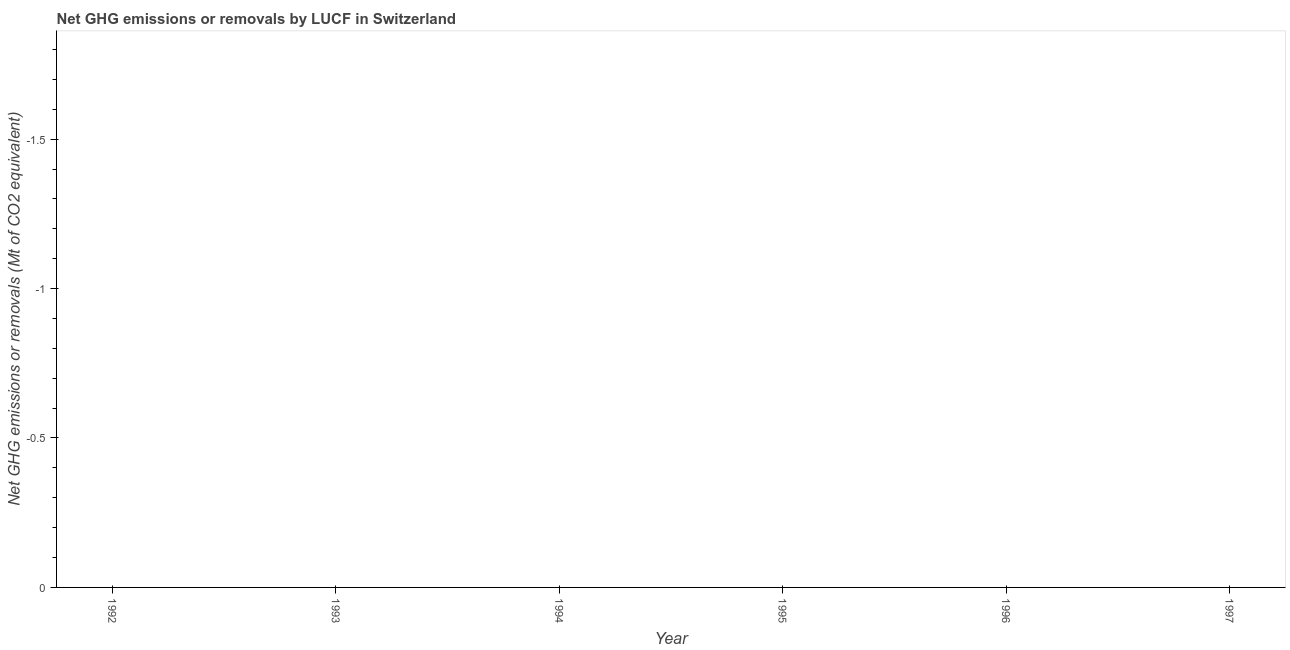What is the ghg net emissions or removals in 1994?
Provide a succinct answer. 0. Across all years, what is the minimum ghg net emissions or removals?
Keep it short and to the point. 0. What is the average ghg net emissions or removals per year?
Make the answer very short. 0. In how many years, is the ghg net emissions or removals greater than -1.3 Mt?
Offer a terse response. 0. In how many years, is the ghg net emissions or removals greater than the average ghg net emissions or removals taken over all years?
Your response must be concise. 0. What is the difference between two consecutive major ticks on the Y-axis?
Your answer should be very brief. 0.5. Does the graph contain any zero values?
Keep it short and to the point. Yes. Does the graph contain grids?
Provide a succinct answer. No. What is the title of the graph?
Provide a succinct answer. Net GHG emissions or removals by LUCF in Switzerland. What is the label or title of the X-axis?
Give a very brief answer. Year. What is the label or title of the Y-axis?
Your response must be concise. Net GHG emissions or removals (Mt of CO2 equivalent). What is the Net GHG emissions or removals (Mt of CO2 equivalent) in 1994?
Provide a short and direct response. 0. What is the Net GHG emissions or removals (Mt of CO2 equivalent) in 1996?
Ensure brevity in your answer.  0. 